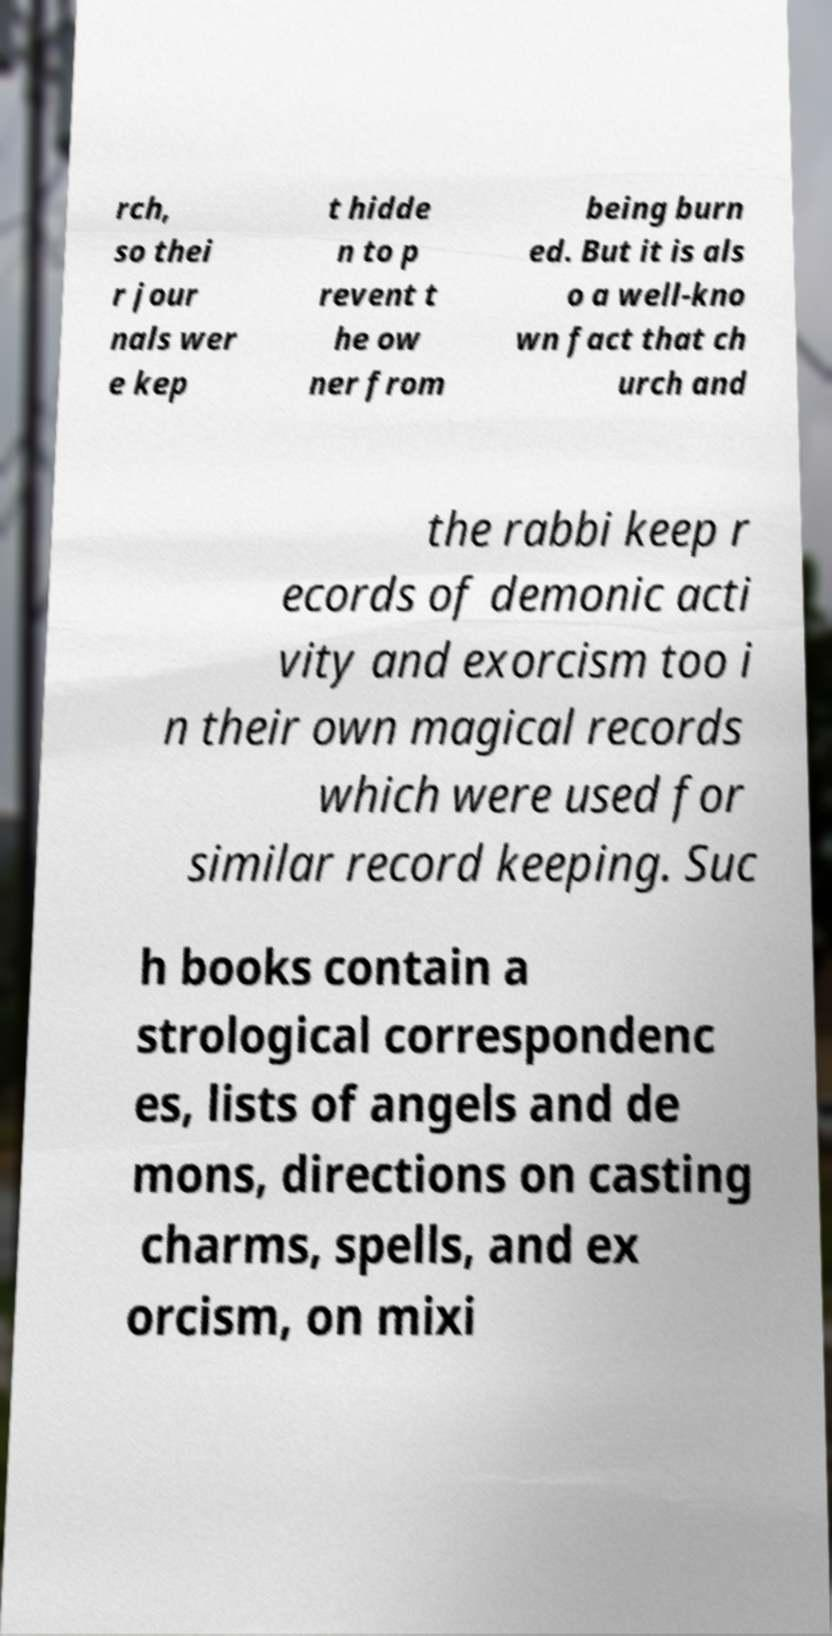Please read and relay the text visible in this image. What does it say? rch, so thei r jour nals wer e kep t hidde n to p revent t he ow ner from being burn ed. But it is als o a well-kno wn fact that ch urch and the rabbi keep r ecords of demonic acti vity and exorcism too i n their own magical records which were used for similar record keeping. Suc h books contain a strological correspondenc es, lists of angels and de mons, directions on casting charms, spells, and ex orcism, on mixi 